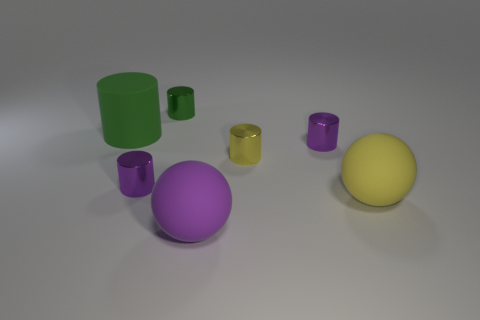There is a cylinder behind the green rubber thing; what is its material?
Give a very brief answer. Metal. There is a small green thing that is the same shape as the yellow metal object; what material is it?
Offer a terse response. Metal. There is a matte ball behind the large purple thing; is there a small yellow metal thing in front of it?
Your response must be concise. No. Does the green rubber thing have the same shape as the big yellow thing?
Your response must be concise. No. There is a green thing that is the same material as the big purple sphere; what shape is it?
Offer a very short reply. Cylinder. Do the yellow thing on the left side of the big yellow ball and the purple metallic cylinder right of the tiny yellow thing have the same size?
Your response must be concise. Yes. Are there more big balls that are behind the large purple sphere than big green things to the right of the big yellow thing?
Offer a very short reply. Yes. What number of other things are the same color as the big cylinder?
Give a very brief answer. 1. There is a big cylinder; does it have the same color as the ball behind the purple rubber sphere?
Ensure brevity in your answer.  No. There is a large thing that is right of the purple ball; what number of big rubber spheres are left of it?
Give a very brief answer. 1. 